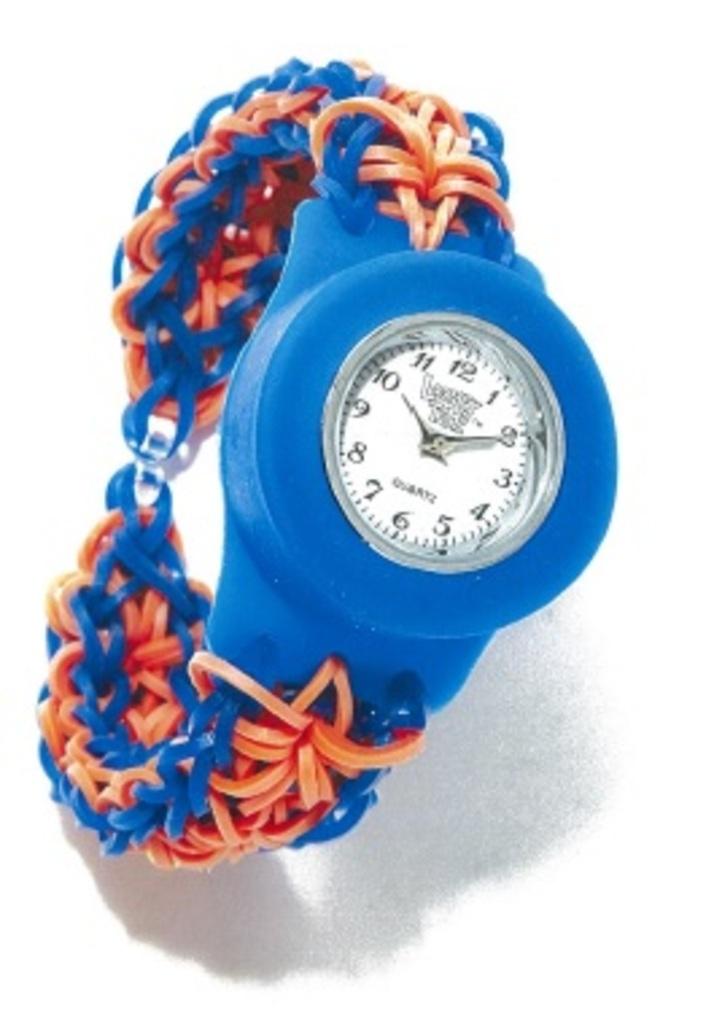What time is it?
Your answer should be compact. 10:10. 